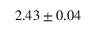Convert formula to latex. <formula><loc_0><loc_0><loc_500><loc_500>2 . 4 3 \pm 0 . 0 4</formula> 